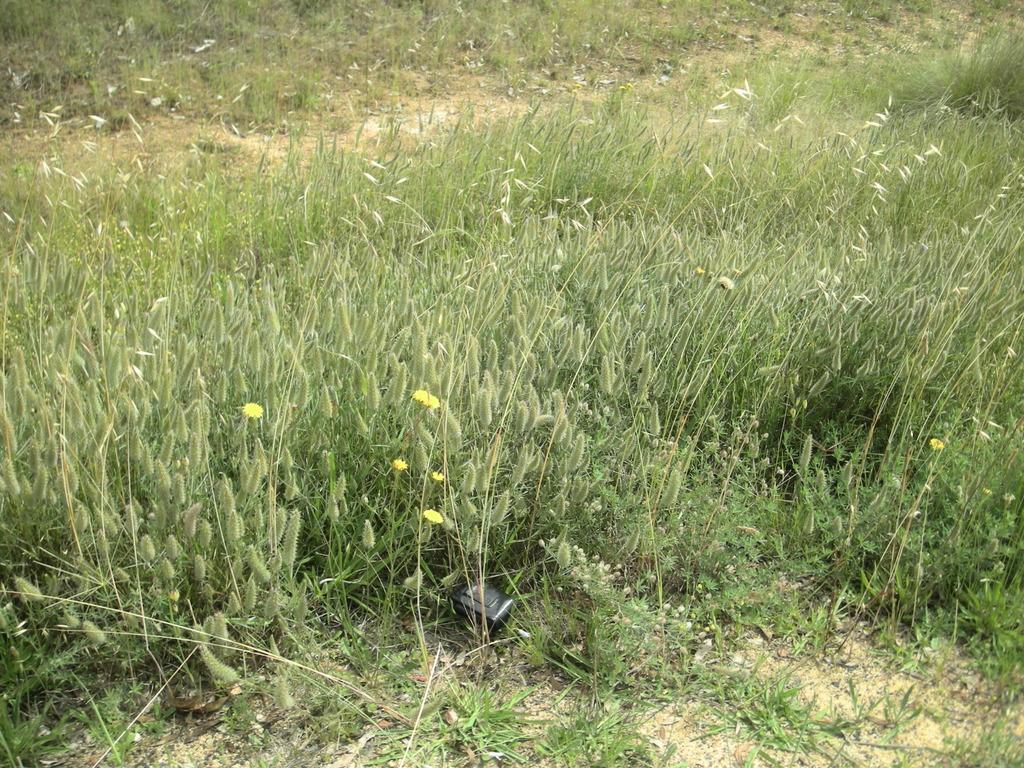In one or two sentences, can you explain what this image depicts? In this image we can see one black object on the ground, some flowers with plants, some buds with plants and some grass on the ground. 